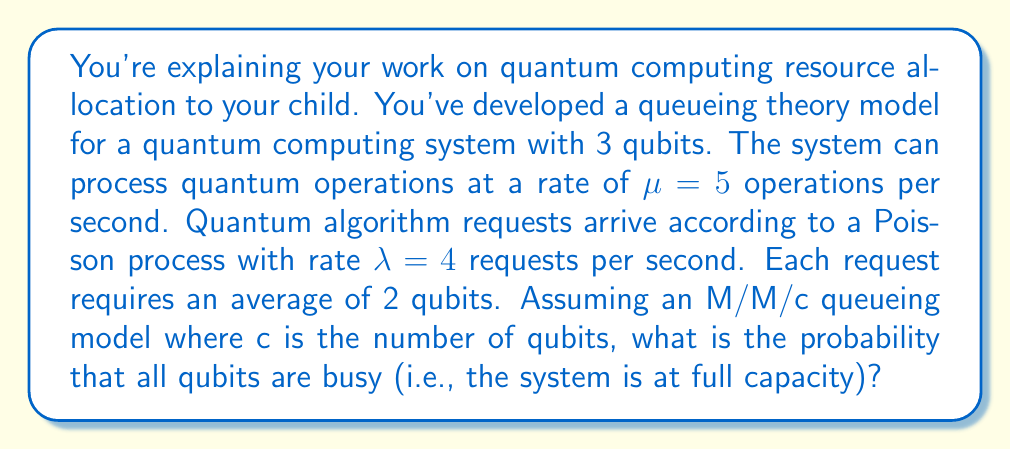Help me with this question. Let's approach this step-by-step:

1) First, we need to identify the queueing model parameters:
   - Number of servers (qubits): $c = 3$
   - Arrival rate: $\lambda = 4$ requests/second
   - Service rate: $\mu = 5$ operations/second
   - Average number of qubits per request: 2

2) We need to calculate the effective service rate per qubit:
   $\mu_{eff} = \mu / 2 = 5 / 2 = 2.5$ requests/second/qubit

3) Now we can calculate the traffic intensity:
   $\rho = \lambda / (c \cdot \mu_{eff}) = 4 / (3 \cdot 2.5) = 4/7.5 \approx 0.533$

4) For an M/M/c queue, the probability of all servers being busy (system at full capacity) is given by the Erlang C formula:

   $$P(W>0) = \frac{(c\rho)^c}{c!(1-\rho)} \cdot P_0$$

   Where $P_0$ is the probability of an empty system:

   $$P_0 = \left[\sum_{n=0}^{c-1}\frac{(c\rho)^n}{n!} + \frac{(c\rho)^c}{c!(1-\rho)}\right]^{-1}$$

5) Let's calculate $P_0$:
   
   $$P_0 = \left[\frac{(3\cdot0.533)^0}{0!} + \frac{(3\cdot0.533)^1}{1!} + \frac{(3\cdot0.533)^2}{2!} + \frac{(3\cdot0.533)^3}{3!(1-0.533)}\right]^{-1}$$
   
   $$P_0 = [1 + 1.599 + 1.279 + 0.912]^{-1} \approx 0.209$$

6) Now we can calculate $P(W>0)$:

   $$P(W>0) = \frac{(3\cdot0.533)^3}{3!(1-0.533)} \cdot 0.209 \approx 0.191$$

Thus, the probability that all qubits are busy is approximately 0.191 or 19.1%.
Answer: The probability that all qubits are busy (system at full capacity) is approximately 0.191 or 19.1%. 